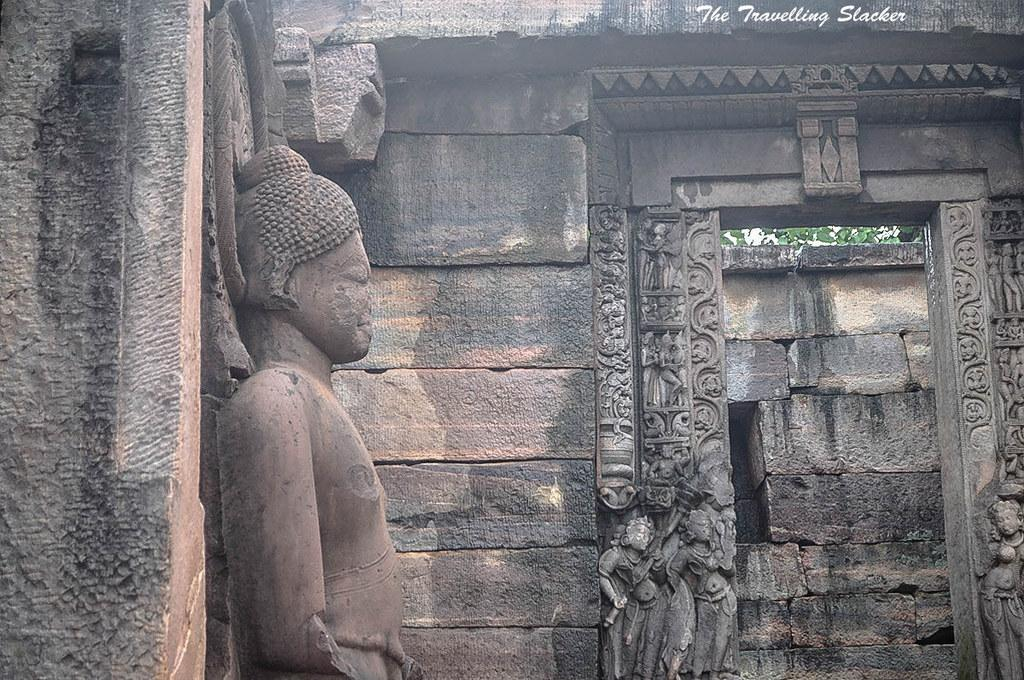What is the main subject in the middle of the image? There is a sculpture in the middle of the image. What can be seen in the background of the image? There is a stone wall in the background of the image. Where is the entrance located in the image? The entrance is on the right side of the image. What type of plantation can be seen in the image? There is no plantation present in the image. Is there a map included in the image? There is no map present in the image. 